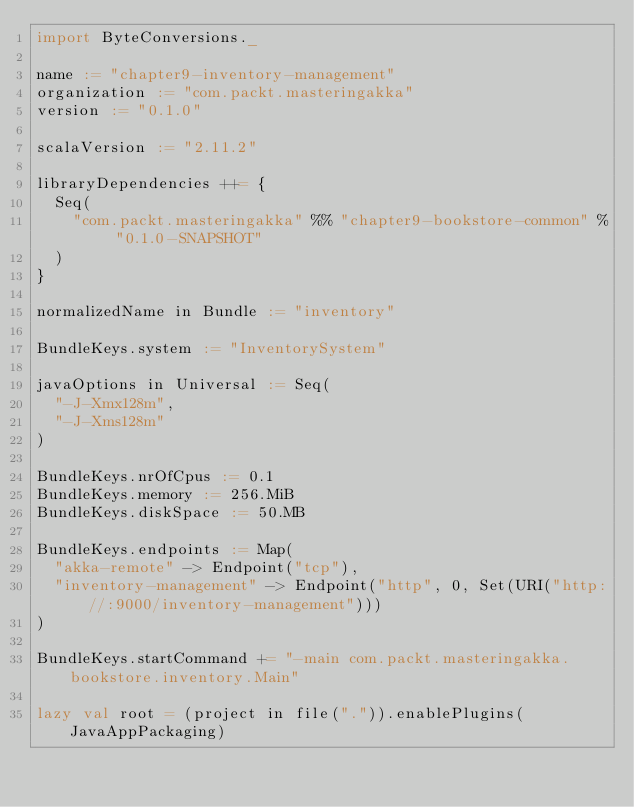<code> <loc_0><loc_0><loc_500><loc_500><_Scala_>import ByteConversions._

name := "chapter9-inventory-management"
organization := "com.packt.masteringakka"
version := "0.1.0"

scalaVersion := "2.11.2"

libraryDependencies ++= {  
  Seq(
    "com.packt.masteringakka" %% "chapter9-bookstore-common" % "0.1.0-SNAPSHOT"
  )
}

normalizedName in Bundle := "inventory"

BundleKeys.system := "InventorySystem"

javaOptions in Universal := Seq(
  "-J-Xmx128m",
  "-J-Xms128m"
)

BundleKeys.nrOfCpus := 0.1
BundleKeys.memory := 256.MiB
BundleKeys.diskSpace := 50.MB

BundleKeys.endpoints := Map(
  "akka-remote" -> Endpoint("tcp"),
  "inventory-management" -> Endpoint("http", 0, Set(URI("http://:9000/inventory-management")))
)

BundleKeys.startCommand += "-main com.packt.masteringakka.bookstore.inventory.Main"

lazy val root = (project in file(".")).enablePlugins(JavaAppPackaging)</code> 